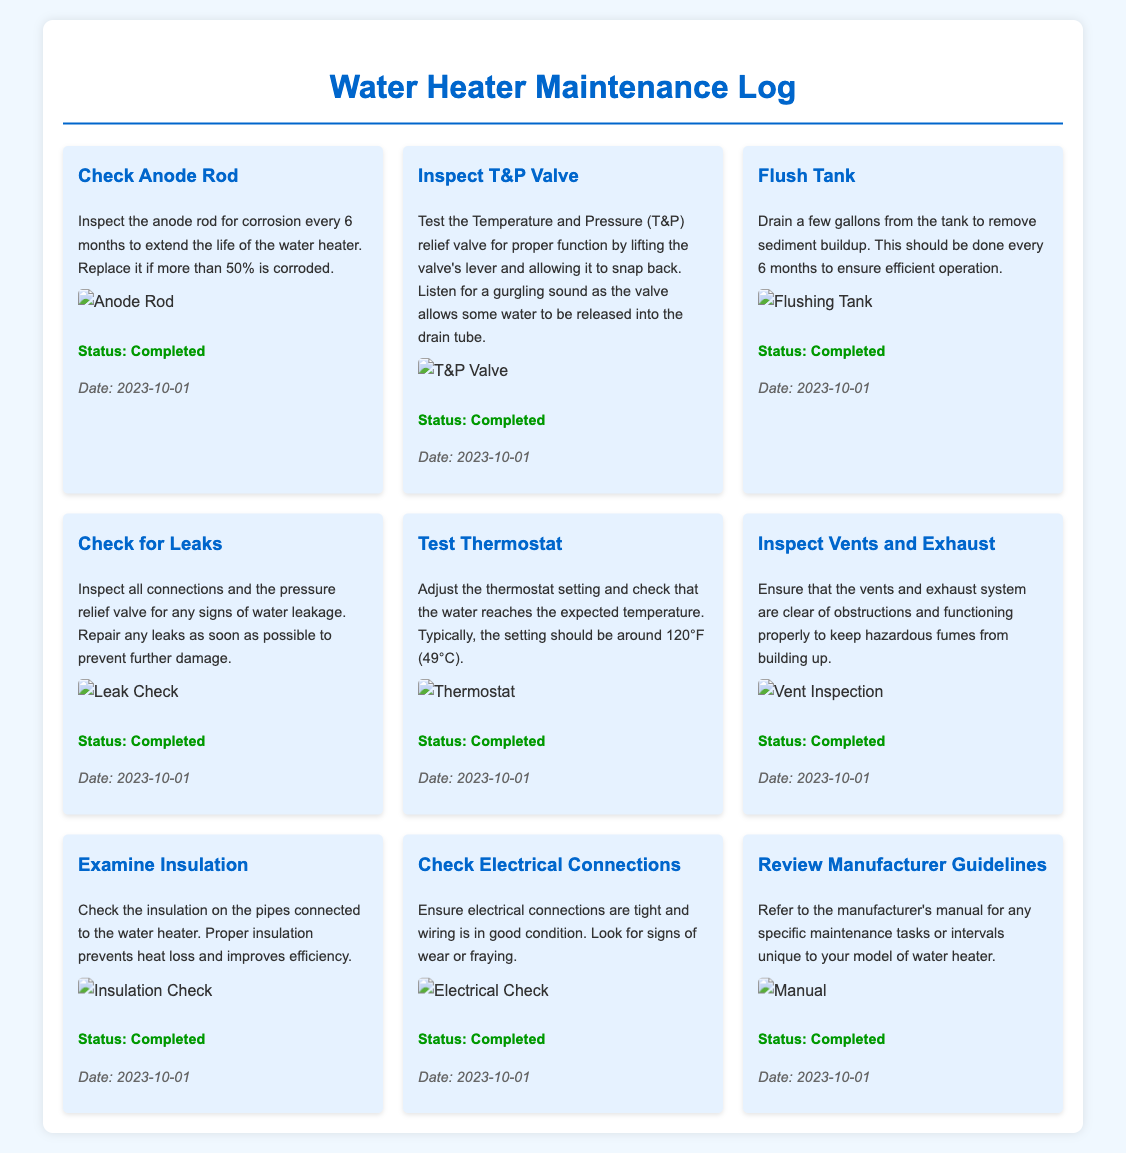What is the first maintenance task listed? The first maintenance task in the checklist is "Check Anode Rod."
Answer: Check Anode Rod On what date was the last maintenance check completed? The last maintenance check was completed on "2023-10-01."
Answer: 2023-10-01 How often should the anode rod be inspected? The document states that the anode rod should be inspected every 6 months.
Answer: 6 months What is the status of the T&P valve inspection? The status of the T&P valve inspection is indicated as "Completed."
Answer: Completed What temperature should the thermostat be set to? The expected thermostat setting should be around "120°F."
Answer: 120°F How many maintenance tasks are listed in total? There are a total of 9 maintenance tasks listed in the log.
Answer: 9 Which item requires draining a few gallons from the tank? The maintenance task that requires draining a few gallons is "Flush Tank."
Answer: Flush Tank What is the purpose of inspecting vents and exhaust? The purpose of inspecting vents and exhaust is to prevent hazardous fumes from building up.
Answer: Prevent hazardous fumes What should be done if leaks are found during the inspection? If leaks are found, they should be repaired as soon as possible.
Answer: Repair leaks 